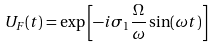<formula> <loc_0><loc_0><loc_500><loc_500>U _ { F } ( t ) = \exp \left [ - i \sigma _ { 1 } \frac { \Omega } { \omega } \sin ( \omega t ) \right ]</formula> 